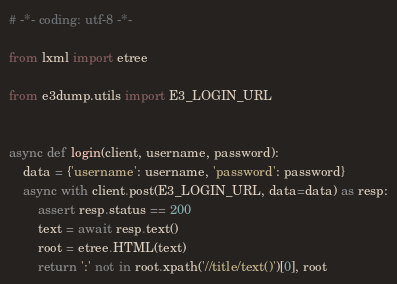<code> <loc_0><loc_0><loc_500><loc_500><_Python_># -*- coding: utf-8 -*-

from lxml import etree

from e3dump.utils import E3_LOGIN_URL


async def login(client, username, password):
    data = {'username': username, 'password': password}
    async with client.post(E3_LOGIN_URL, data=data) as resp:
        assert resp.status == 200
        text = await resp.text()
        root = etree.HTML(text)
        return ':' not in root.xpath('//title/text()')[0], root
</code> 